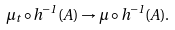Convert formula to latex. <formula><loc_0><loc_0><loc_500><loc_500>\mu _ { t } \circ h ^ { - 1 } ( A ) \rightarrow \mu \circ h ^ { - 1 } ( A ) .</formula> 